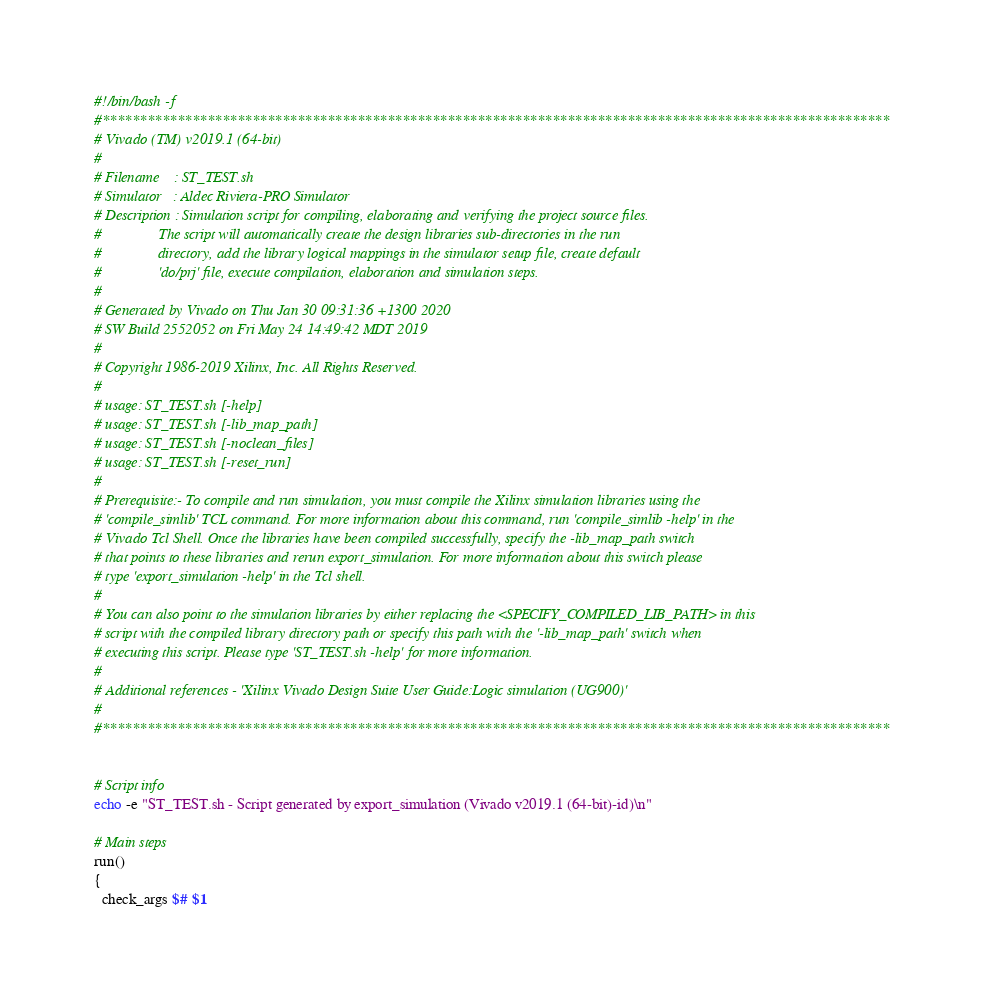Convert code to text. <code><loc_0><loc_0><loc_500><loc_500><_Bash_>#!/bin/bash -f
#*********************************************************************************************************
# Vivado (TM) v2019.1 (64-bit)
#
# Filename    : ST_TEST.sh
# Simulator   : Aldec Riviera-PRO Simulator
# Description : Simulation script for compiling, elaborating and verifying the project source files.
#               The script will automatically create the design libraries sub-directories in the run
#               directory, add the library logical mappings in the simulator setup file, create default
#               'do/prj' file, execute compilation, elaboration and simulation steps.
#
# Generated by Vivado on Thu Jan 30 09:31:36 +1300 2020
# SW Build 2552052 on Fri May 24 14:49:42 MDT 2019
#
# Copyright 1986-2019 Xilinx, Inc. All Rights Reserved. 
#
# usage: ST_TEST.sh [-help]
# usage: ST_TEST.sh [-lib_map_path]
# usage: ST_TEST.sh [-noclean_files]
# usage: ST_TEST.sh [-reset_run]
#
# Prerequisite:- To compile and run simulation, you must compile the Xilinx simulation libraries using the
# 'compile_simlib' TCL command. For more information about this command, run 'compile_simlib -help' in the
# Vivado Tcl Shell. Once the libraries have been compiled successfully, specify the -lib_map_path switch
# that points to these libraries and rerun export_simulation. For more information about this switch please
# type 'export_simulation -help' in the Tcl shell.
#
# You can also point to the simulation libraries by either replacing the <SPECIFY_COMPILED_LIB_PATH> in this
# script with the compiled library directory path or specify this path with the '-lib_map_path' switch when
# executing this script. Please type 'ST_TEST.sh -help' for more information.
#
# Additional references - 'Xilinx Vivado Design Suite User Guide:Logic simulation (UG900)'
#
#*********************************************************************************************************


# Script info
echo -e "ST_TEST.sh - Script generated by export_simulation (Vivado v2019.1 (64-bit)-id)\n"

# Main steps
run()
{
  check_args $# $1</code> 